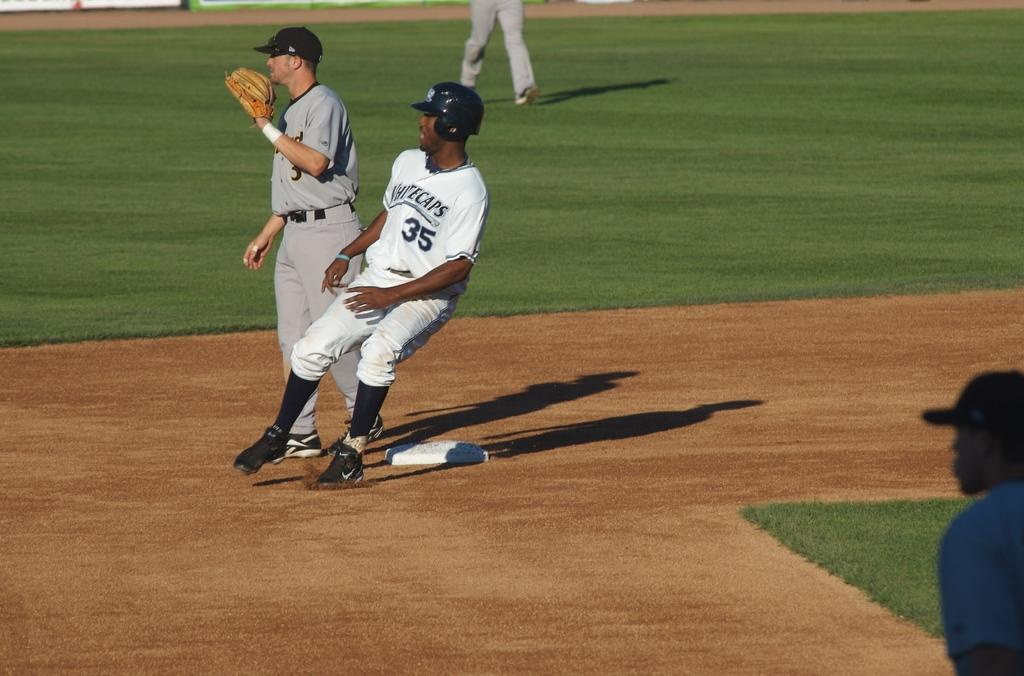Provide a one-sentence caption for the provided image. A baseball game featuring runner number 35 of the whitecaps. 